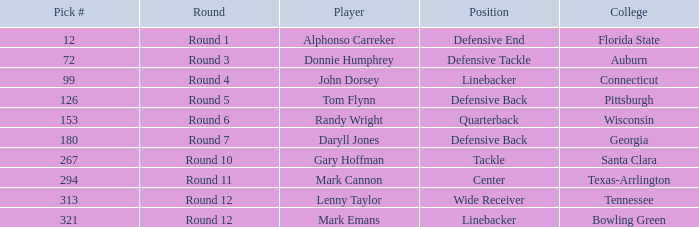In what Round was a player from College of Connecticut drafted? Round 4. 